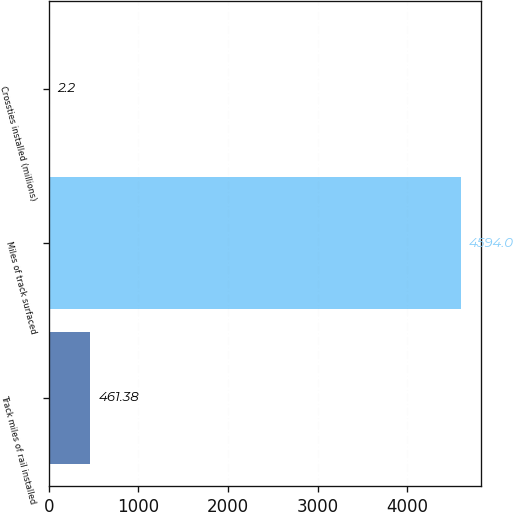Convert chart. <chart><loc_0><loc_0><loc_500><loc_500><bar_chart><fcel>Track miles of rail installed<fcel>Miles of track surfaced<fcel>Crossties installed (millions)<nl><fcel>461.38<fcel>4594<fcel>2.2<nl></chart> 